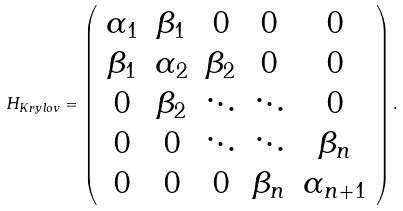Convert formula to latex. <formula><loc_0><loc_0><loc_500><loc_500>H _ { K r y l o v } = \left ( \begin{array} { c c c c c } \alpha _ { 1 } & \beta _ { 1 } & 0 & 0 & 0 \\ \beta _ { 1 } & \alpha _ { 2 } & \beta _ { 2 } & 0 & 0 \\ 0 & \beta _ { 2 } & \ddots & \ddots & 0 \\ 0 & 0 & \ddots & \ddots & \beta _ { n } \\ 0 & 0 & 0 & \beta _ { n } & \alpha _ { n + 1 } \end{array} \right ) .</formula> 